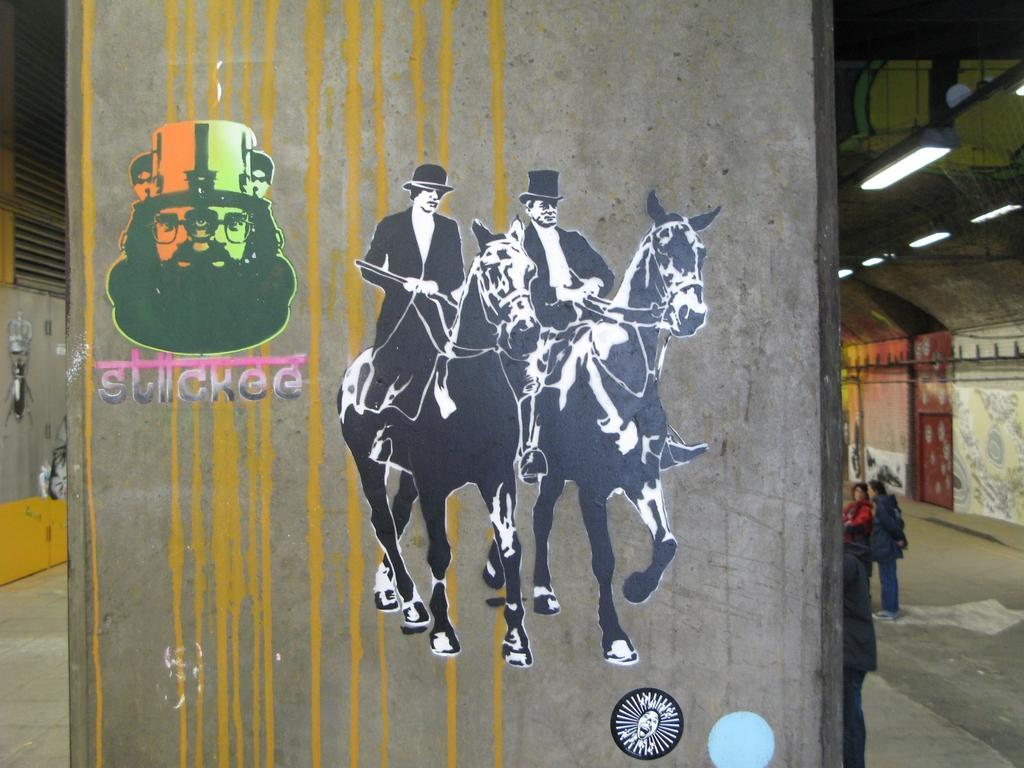Describe this image in one or two sentences. In this image there is a painting on the wall which has two men riding horses. 